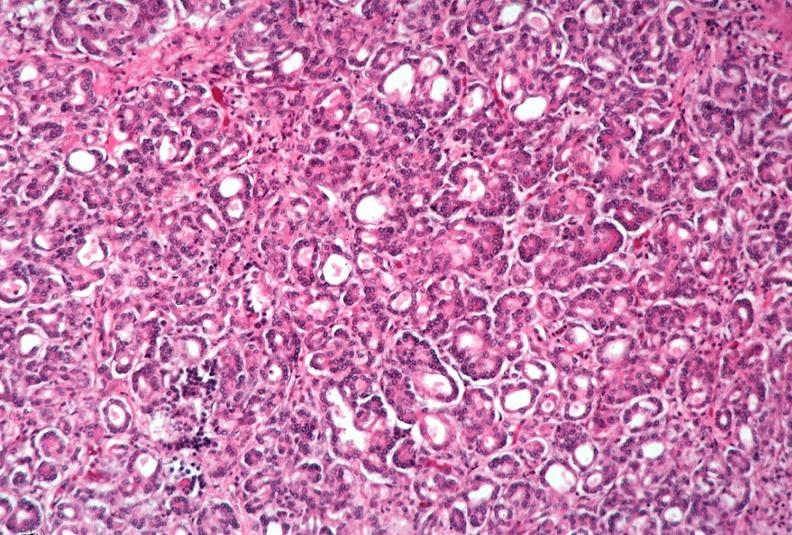does this image show pancreas, uremic pancreatitis due to polycystic kidney?
Answer the question using a single word or phrase. Yes 